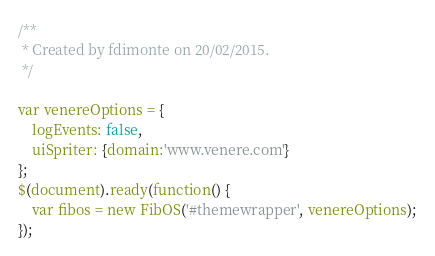<code> <loc_0><loc_0><loc_500><loc_500><_JavaScript_>/**
 * Created by fdimonte on 20/02/2015.
 */

var venereOptions = {
    logEvents: false,
    uiSpriter: {domain:'www.venere.com'}
};
$(document).ready(function() {
    var fibos = new FibOS('#themewrapper', venereOptions);
});
</code> 